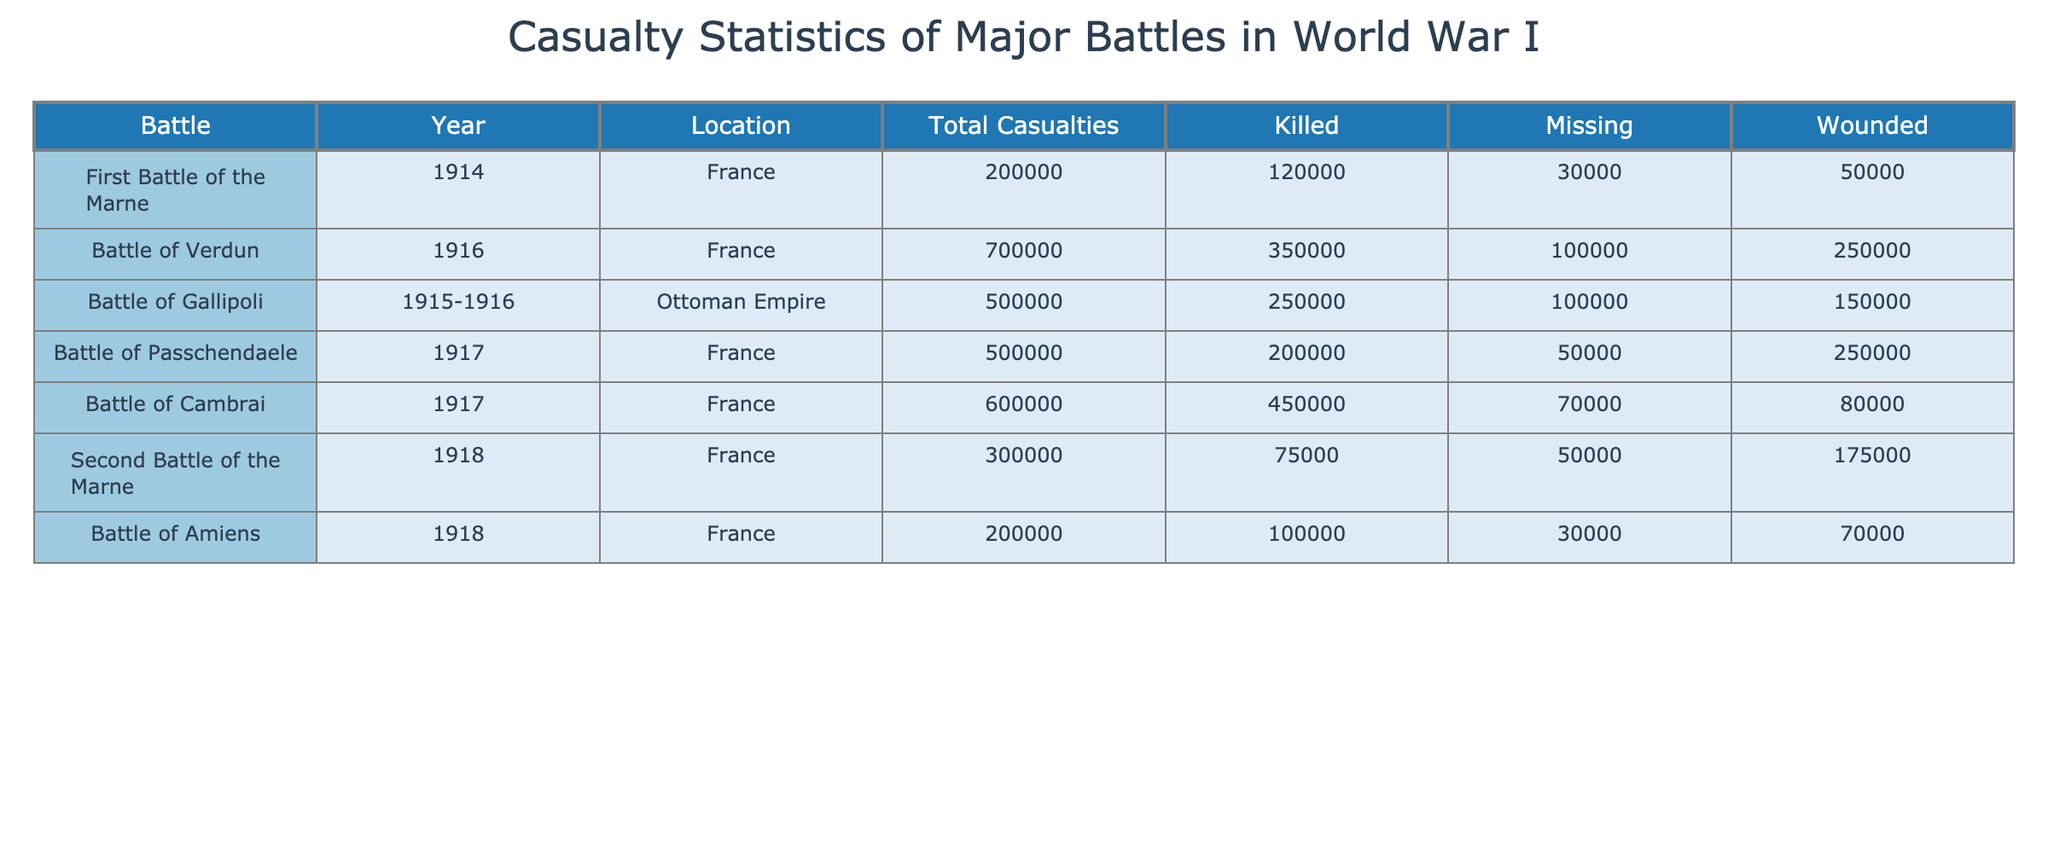What was the total number of casualties in the Battle of Verdun? In the table, I find the row for the Battle of Verdun, which shows the Total Casualties column with a value of 700000.
Answer: 700000 How many soldiers were killed in the Battle of Cambrai? Looking at the row for the Battle of Cambrai, the Killed column indicates that 450000 soldiers were killed in that battle.
Answer: 450000 What is the total number of missing soldiers across all battles? By summing the values in the Missing column: 30000 (First Battle of the Marne) + 100000 (Battle of Verdun) + 100000 (Battle of Gallipoli) + 50000 (Battle of Passchendaele) + 70000 (Battle of Cambrai) + 50000 (Second Battle of the Marne) + 30000 (Battle of Amiens) = 360000.
Answer: 360000 Was the total number of wounded in the Battle of Passchendaele greater than that in the Battle of Amiens? From the table, the Wounded column for Passchendaele shows 250000 and for Amiens shows 70000. Therefore, 250000 is greater than 70000, meaning the statement is true.
Answer: Yes What battle had the highest number of missing soldiers, and how many were there? Examining the Missing column, I notice that the highest value corresponds to the Battle of Gallipoli with 100000 missing soldiers, which is greater than missing figures from other battles.
Answer: Battle of Gallipoli, 100000 Which battle had the least total casualties, and what was the total? By comparing all the Total Casualties values in the table, the First Battle of the Marne has the least with 200000 casualties.
Answer: First Battle of the Marne, 200000 What is the average number of casualties across all battles listed? To find the average, first sum the total casualties: 200000 + 700000 + 500000 + 500000 + 600000 + 300000 + 200000 = 3100000. Then divide by the number of battles (7): 3100000 / 7 = 442857.14, thus the average is about 442857 when rounded.
Answer: 442857 How many total casualties were there in battles that occurred in 1917? The battles in 1917, the Battle of Passchendaele and the Battle of Cambrai, have totals of 500000 and 600000 respectively, which sum to 1100000.
Answer: 1100000 